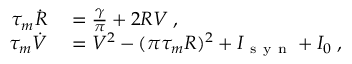<formula> <loc_0><loc_0><loc_500><loc_500>\begin{array} { r l } { \tau _ { m } \dot { R } } & = \frac { \gamma } { \pi } + 2 R V \, , } \\ { \tau _ { m } \dot { V } } & = V ^ { 2 } - ( \pi \tau _ { m } R ) ^ { 2 } + I _ { s y n } + I _ { 0 } \, , } \end{array}</formula> 